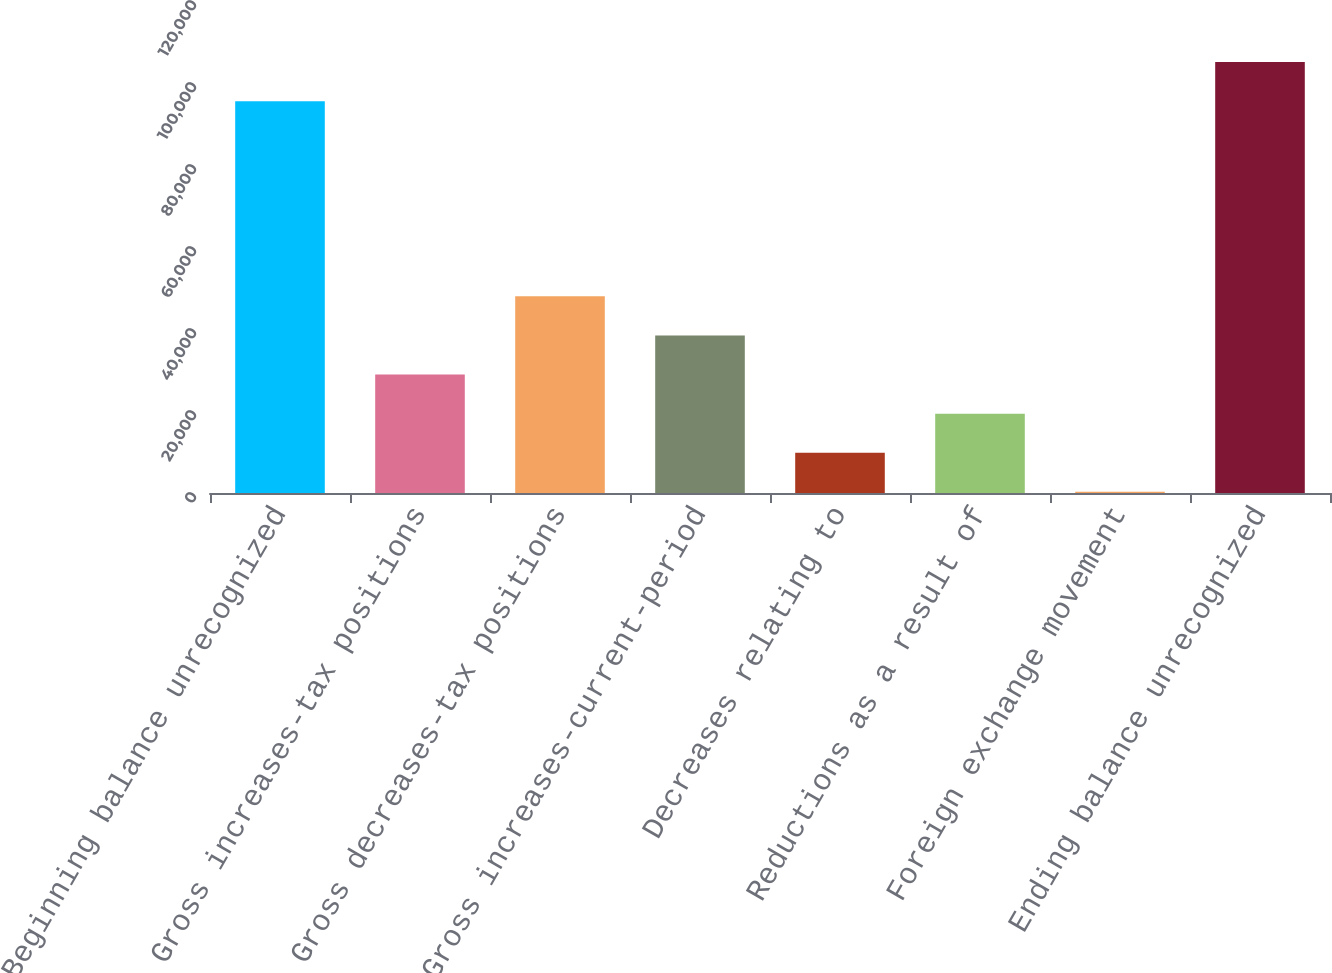Convert chart to OTSL. <chart><loc_0><loc_0><loc_500><loc_500><bar_chart><fcel>Beginning balance unrecognized<fcel>Gross increases-tax positions<fcel>Gross decreases-tax positions<fcel>Gross increases-current-period<fcel>Decreases relating to<fcel>Reductions as a result of<fcel>Foreign exchange movement<fcel>Ending balance unrecognized<nl><fcel>95575<fcel>28894.5<fcel>47971.5<fcel>38433<fcel>9817.5<fcel>19356<fcel>279<fcel>105114<nl></chart> 